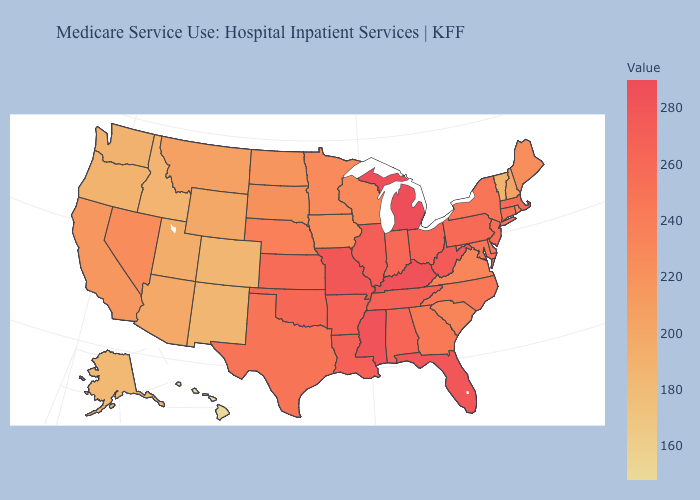Which states have the lowest value in the USA?
Keep it brief. Hawaii. Among the states that border South Dakota , does Wyoming have the highest value?
Keep it brief. No. Does Oklahoma have a higher value than Washington?
Write a very short answer. Yes. 